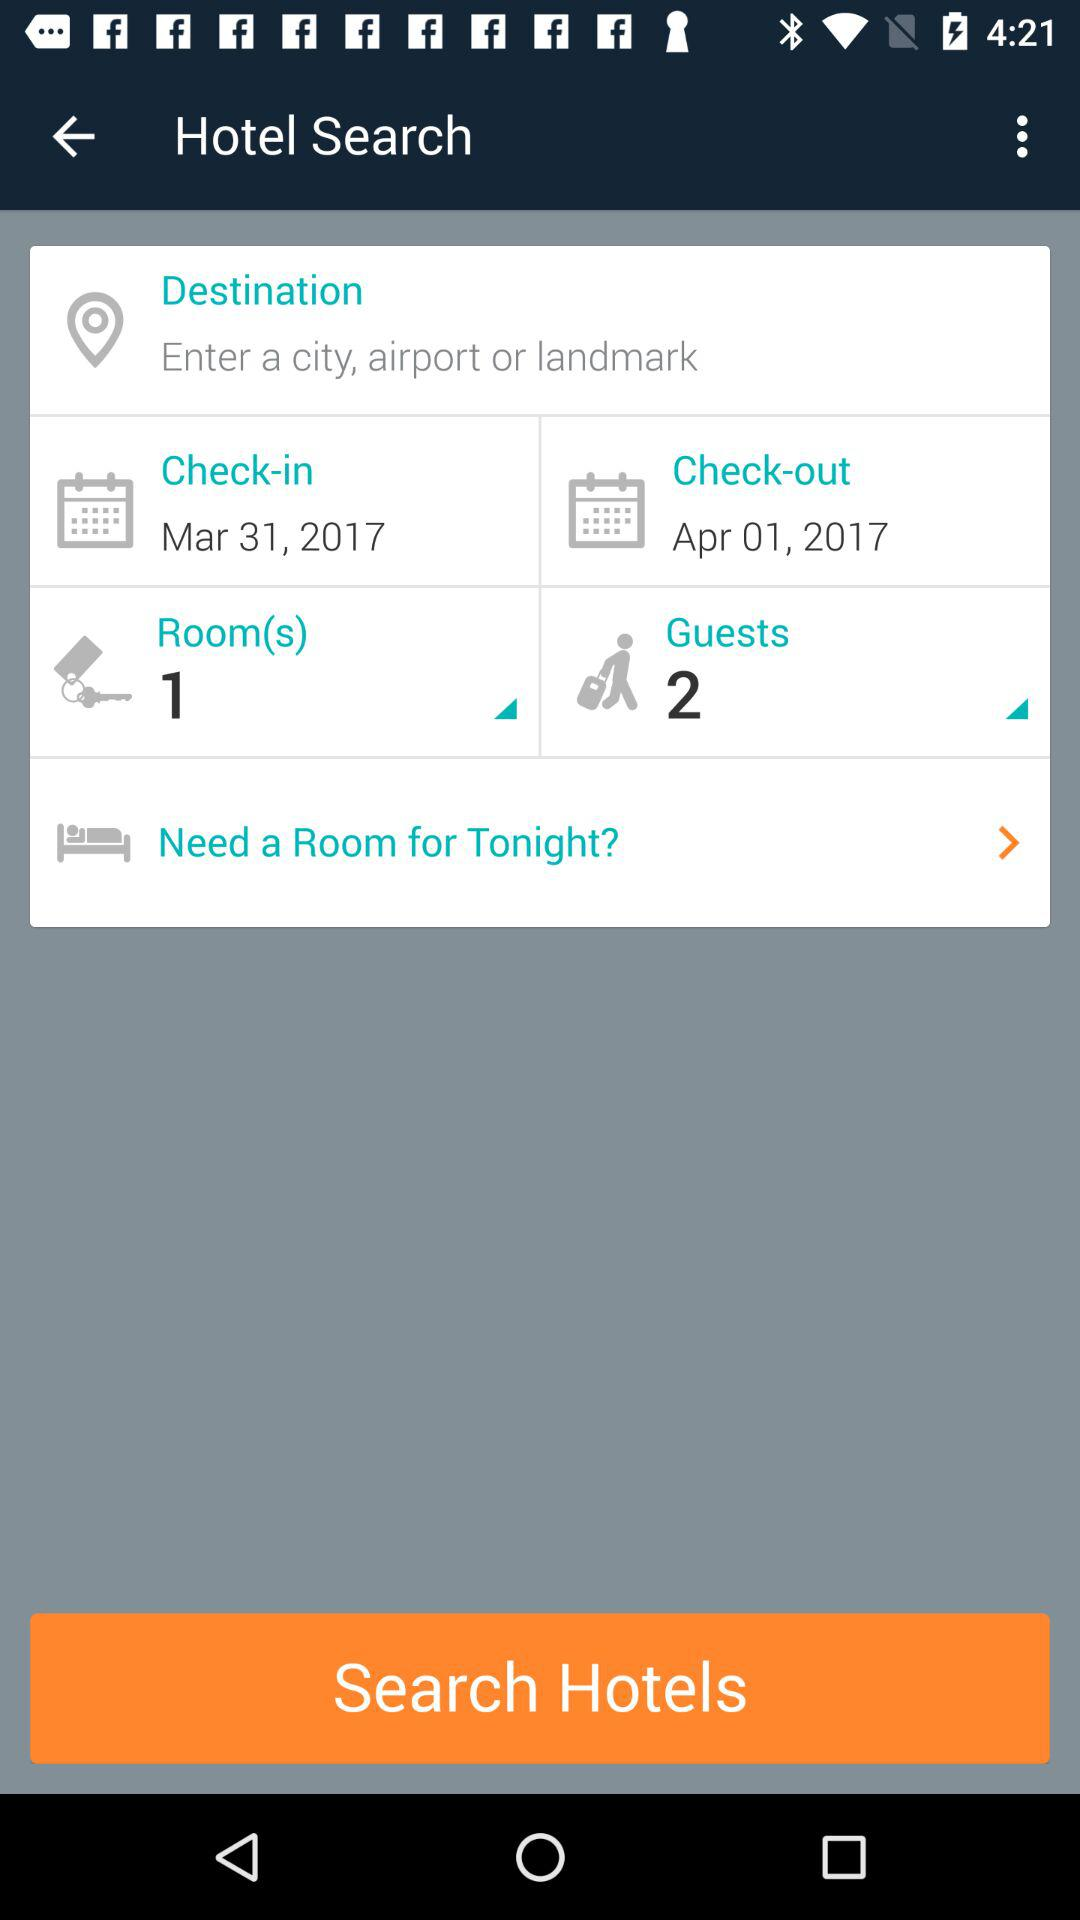What is the check-in date? The check-in date is March 31, 2017. 